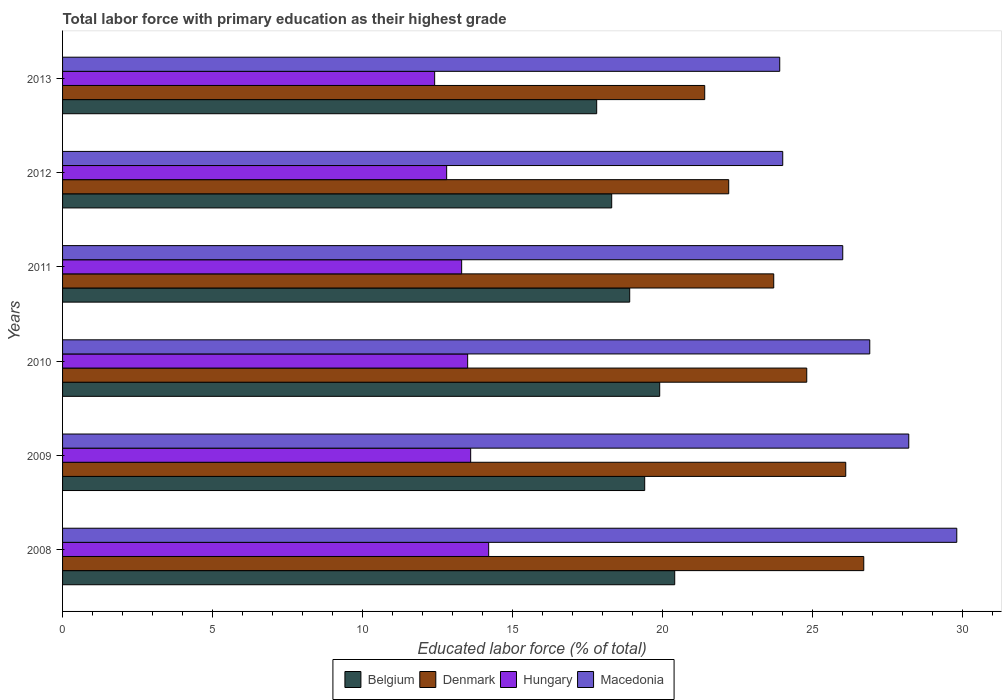How many groups of bars are there?
Ensure brevity in your answer.  6. Are the number of bars per tick equal to the number of legend labels?
Make the answer very short. Yes. How many bars are there on the 6th tick from the top?
Make the answer very short. 4. What is the label of the 2nd group of bars from the top?
Offer a very short reply. 2012. What is the percentage of total labor force with primary education in Hungary in 2013?
Ensure brevity in your answer.  12.4. Across all years, what is the maximum percentage of total labor force with primary education in Denmark?
Offer a terse response. 26.7. Across all years, what is the minimum percentage of total labor force with primary education in Denmark?
Offer a terse response. 21.4. What is the total percentage of total labor force with primary education in Belgium in the graph?
Keep it short and to the point. 114.7. What is the difference between the percentage of total labor force with primary education in Denmark in 2008 and that in 2010?
Offer a very short reply. 1.9. What is the difference between the percentage of total labor force with primary education in Belgium in 2010 and the percentage of total labor force with primary education in Macedonia in 2011?
Your response must be concise. -6.1. What is the average percentage of total labor force with primary education in Macedonia per year?
Make the answer very short. 26.47. In the year 2009, what is the difference between the percentage of total labor force with primary education in Macedonia and percentage of total labor force with primary education in Denmark?
Give a very brief answer. 2.1. What is the ratio of the percentage of total labor force with primary education in Macedonia in 2010 to that in 2011?
Your answer should be very brief. 1.03. What is the difference between the highest and the second highest percentage of total labor force with primary education in Macedonia?
Your response must be concise. 1.6. What is the difference between the highest and the lowest percentage of total labor force with primary education in Belgium?
Your response must be concise. 2.6. In how many years, is the percentage of total labor force with primary education in Denmark greater than the average percentage of total labor force with primary education in Denmark taken over all years?
Provide a succinct answer. 3. Are all the bars in the graph horizontal?
Make the answer very short. Yes. How many years are there in the graph?
Give a very brief answer. 6. Are the values on the major ticks of X-axis written in scientific E-notation?
Your response must be concise. No. Does the graph contain any zero values?
Your response must be concise. No. What is the title of the graph?
Ensure brevity in your answer.  Total labor force with primary education as their highest grade. Does "Burundi" appear as one of the legend labels in the graph?
Your response must be concise. No. What is the label or title of the X-axis?
Provide a short and direct response. Educated labor force (% of total). What is the Educated labor force (% of total) in Belgium in 2008?
Your answer should be very brief. 20.4. What is the Educated labor force (% of total) of Denmark in 2008?
Provide a short and direct response. 26.7. What is the Educated labor force (% of total) of Hungary in 2008?
Your answer should be very brief. 14.2. What is the Educated labor force (% of total) of Macedonia in 2008?
Give a very brief answer. 29.8. What is the Educated labor force (% of total) in Belgium in 2009?
Provide a succinct answer. 19.4. What is the Educated labor force (% of total) of Denmark in 2009?
Offer a very short reply. 26.1. What is the Educated labor force (% of total) of Hungary in 2009?
Offer a terse response. 13.6. What is the Educated labor force (% of total) of Macedonia in 2009?
Offer a terse response. 28.2. What is the Educated labor force (% of total) in Belgium in 2010?
Ensure brevity in your answer.  19.9. What is the Educated labor force (% of total) of Denmark in 2010?
Your answer should be very brief. 24.8. What is the Educated labor force (% of total) of Macedonia in 2010?
Your answer should be very brief. 26.9. What is the Educated labor force (% of total) of Belgium in 2011?
Offer a terse response. 18.9. What is the Educated labor force (% of total) in Denmark in 2011?
Offer a very short reply. 23.7. What is the Educated labor force (% of total) in Hungary in 2011?
Offer a very short reply. 13.3. What is the Educated labor force (% of total) of Macedonia in 2011?
Make the answer very short. 26. What is the Educated labor force (% of total) of Belgium in 2012?
Your answer should be compact. 18.3. What is the Educated labor force (% of total) of Denmark in 2012?
Your answer should be compact. 22.2. What is the Educated labor force (% of total) in Hungary in 2012?
Your response must be concise. 12.8. What is the Educated labor force (% of total) of Macedonia in 2012?
Offer a terse response. 24. What is the Educated labor force (% of total) of Belgium in 2013?
Your answer should be very brief. 17.8. What is the Educated labor force (% of total) of Denmark in 2013?
Provide a short and direct response. 21.4. What is the Educated labor force (% of total) in Hungary in 2013?
Your response must be concise. 12.4. What is the Educated labor force (% of total) in Macedonia in 2013?
Provide a succinct answer. 23.9. Across all years, what is the maximum Educated labor force (% of total) in Belgium?
Keep it short and to the point. 20.4. Across all years, what is the maximum Educated labor force (% of total) of Denmark?
Give a very brief answer. 26.7. Across all years, what is the maximum Educated labor force (% of total) in Hungary?
Ensure brevity in your answer.  14.2. Across all years, what is the maximum Educated labor force (% of total) of Macedonia?
Your answer should be compact. 29.8. Across all years, what is the minimum Educated labor force (% of total) in Belgium?
Make the answer very short. 17.8. Across all years, what is the minimum Educated labor force (% of total) in Denmark?
Make the answer very short. 21.4. Across all years, what is the minimum Educated labor force (% of total) of Hungary?
Offer a terse response. 12.4. Across all years, what is the minimum Educated labor force (% of total) of Macedonia?
Make the answer very short. 23.9. What is the total Educated labor force (% of total) of Belgium in the graph?
Give a very brief answer. 114.7. What is the total Educated labor force (% of total) of Denmark in the graph?
Keep it short and to the point. 144.9. What is the total Educated labor force (% of total) in Hungary in the graph?
Keep it short and to the point. 79.8. What is the total Educated labor force (% of total) of Macedonia in the graph?
Your answer should be very brief. 158.8. What is the difference between the Educated labor force (% of total) in Macedonia in 2008 and that in 2010?
Provide a succinct answer. 2.9. What is the difference between the Educated labor force (% of total) in Denmark in 2008 and that in 2011?
Provide a short and direct response. 3. What is the difference between the Educated labor force (% of total) of Macedonia in 2008 and that in 2011?
Provide a succinct answer. 3.8. What is the difference between the Educated labor force (% of total) of Belgium in 2008 and that in 2012?
Your response must be concise. 2.1. What is the difference between the Educated labor force (% of total) of Denmark in 2008 and that in 2012?
Offer a very short reply. 4.5. What is the difference between the Educated labor force (% of total) of Hungary in 2008 and that in 2012?
Give a very brief answer. 1.4. What is the difference between the Educated labor force (% of total) in Macedonia in 2008 and that in 2012?
Provide a succinct answer. 5.8. What is the difference between the Educated labor force (% of total) of Belgium in 2008 and that in 2013?
Your answer should be very brief. 2.6. What is the difference between the Educated labor force (% of total) of Denmark in 2008 and that in 2013?
Ensure brevity in your answer.  5.3. What is the difference between the Educated labor force (% of total) in Belgium in 2009 and that in 2010?
Offer a terse response. -0.5. What is the difference between the Educated labor force (% of total) of Denmark in 2009 and that in 2010?
Your answer should be compact. 1.3. What is the difference between the Educated labor force (% of total) of Hungary in 2009 and that in 2010?
Make the answer very short. 0.1. What is the difference between the Educated labor force (% of total) of Macedonia in 2009 and that in 2010?
Make the answer very short. 1.3. What is the difference between the Educated labor force (% of total) of Macedonia in 2009 and that in 2011?
Your answer should be very brief. 2.2. What is the difference between the Educated labor force (% of total) in Hungary in 2009 and that in 2012?
Keep it short and to the point. 0.8. What is the difference between the Educated labor force (% of total) of Macedonia in 2009 and that in 2012?
Make the answer very short. 4.2. What is the difference between the Educated labor force (% of total) of Belgium in 2009 and that in 2013?
Give a very brief answer. 1.6. What is the difference between the Educated labor force (% of total) in Hungary in 2009 and that in 2013?
Give a very brief answer. 1.2. What is the difference between the Educated labor force (% of total) in Macedonia in 2009 and that in 2013?
Offer a very short reply. 4.3. What is the difference between the Educated labor force (% of total) of Denmark in 2010 and that in 2011?
Your answer should be very brief. 1.1. What is the difference between the Educated labor force (% of total) in Denmark in 2010 and that in 2012?
Ensure brevity in your answer.  2.6. What is the difference between the Educated labor force (% of total) in Hungary in 2010 and that in 2012?
Ensure brevity in your answer.  0.7. What is the difference between the Educated labor force (% of total) in Belgium in 2010 and that in 2013?
Keep it short and to the point. 2.1. What is the difference between the Educated labor force (% of total) in Denmark in 2011 and that in 2012?
Your response must be concise. 1.5. What is the difference between the Educated labor force (% of total) in Hungary in 2011 and that in 2012?
Keep it short and to the point. 0.5. What is the difference between the Educated labor force (% of total) of Macedonia in 2011 and that in 2012?
Offer a very short reply. 2. What is the difference between the Educated labor force (% of total) in Macedonia in 2011 and that in 2013?
Your answer should be compact. 2.1. What is the difference between the Educated labor force (% of total) in Belgium in 2012 and that in 2013?
Your answer should be compact. 0.5. What is the difference between the Educated labor force (% of total) in Hungary in 2012 and that in 2013?
Your answer should be very brief. 0.4. What is the difference between the Educated labor force (% of total) in Belgium in 2008 and the Educated labor force (% of total) in Denmark in 2009?
Give a very brief answer. -5.7. What is the difference between the Educated labor force (% of total) of Denmark in 2008 and the Educated labor force (% of total) of Hungary in 2009?
Offer a terse response. 13.1. What is the difference between the Educated labor force (% of total) in Hungary in 2008 and the Educated labor force (% of total) in Macedonia in 2009?
Ensure brevity in your answer.  -14. What is the difference between the Educated labor force (% of total) of Belgium in 2008 and the Educated labor force (% of total) of Hungary in 2010?
Make the answer very short. 6.9. What is the difference between the Educated labor force (% of total) in Denmark in 2008 and the Educated labor force (% of total) in Macedonia in 2010?
Your response must be concise. -0.2. What is the difference between the Educated labor force (% of total) of Belgium in 2008 and the Educated labor force (% of total) of Macedonia in 2011?
Make the answer very short. -5.6. What is the difference between the Educated labor force (% of total) of Denmark in 2008 and the Educated labor force (% of total) of Hungary in 2011?
Keep it short and to the point. 13.4. What is the difference between the Educated labor force (% of total) of Denmark in 2008 and the Educated labor force (% of total) of Macedonia in 2011?
Give a very brief answer. 0.7. What is the difference between the Educated labor force (% of total) in Hungary in 2008 and the Educated labor force (% of total) in Macedonia in 2011?
Offer a terse response. -11.8. What is the difference between the Educated labor force (% of total) of Belgium in 2008 and the Educated labor force (% of total) of Denmark in 2012?
Keep it short and to the point. -1.8. What is the difference between the Educated labor force (% of total) in Denmark in 2008 and the Educated labor force (% of total) in Hungary in 2012?
Your answer should be compact. 13.9. What is the difference between the Educated labor force (% of total) of Belgium in 2008 and the Educated labor force (% of total) of Denmark in 2013?
Keep it short and to the point. -1. What is the difference between the Educated labor force (% of total) in Belgium in 2008 and the Educated labor force (% of total) in Hungary in 2013?
Offer a terse response. 8. What is the difference between the Educated labor force (% of total) in Belgium in 2008 and the Educated labor force (% of total) in Macedonia in 2013?
Make the answer very short. -3.5. What is the difference between the Educated labor force (% of total) of Denmark in 2008 and the Educated labor force (% of total) of Macedonia in 2013?
Give a very brief answer. 2.8. What is the difference between the Educated labor force (% of total) in Belgium in 2009 and the Educated labor force (% of total) in Hungary in 2010?
Make the answer very short. 5.9. What is the difference between the Educated labor force (% of total) in Belgium in 2009 and the Educated labor force (% of total) in Macedonia in 2010?
Offer a terse response. -7.5. What is the difference between the Educated labor force (% of total) of Belgium in 2009 and the Educated labor force (% of total) of Hungary in 2011?
Provide a succinct answer. 6.1. What is the difference between the Educated labor force (% of total) of Belgium in 2009 and the Educated labor force (% of total) of Macedonia in 2011?
Your response must be concise. -6.6. What is the difference between the Educated labor force (% of total) of Denmark in 2009 and the Educated labor force (% of total) of Hungary in 2011?
Your answer should be very brief. 12.8. What is the difference between the Educated labor force (% of total) in Denmark in 2009 and the Educated labor force (% of total) in Macedonia in 2011?
Offer a terse response. 0.1. What is the difference between the Educated labor force (% of total) of Hungary in 2009 and the Educated labor force (% of total) of Macedonia in 2011?
Give a very brief answer. -12.4. What is the difference between the Educated labor force (% of total) of Belgium in 2009 and the Educated labor force (% of total) of Macedonia in 2012?
Offer a very short reply. -4.6. What is the difference between the Educated labor force (% of total) of Denmark in 2009 and the Educated labor force (% of total) of Macedonia in 2012?
Provide a short and direct response. 2.1. What is the difference between the Educated labor force (% of total) of Hungary in 2009 and the Educated labor force (% of total) of Macedonia in 2012?
Offer a very short reply. -10.4. What is the difference between the Educated labor force (% of total) of Belgium in 2009 and the Educated labor force (% of total) of Denmark in 2013?
Make the answer very short. -2. What is the difference between the Educated labor force (% of total) of Belgium in 2009 and the Educated labor force (% of total) of Hungary in 2013?
Keep it short and to the point. 7. What is the difference between the Educated labor force (% of total) in Denmark in 2009 and the Educated labor force (% of total) in Hungary in 2013?
Your answer should be compact. 13.7. What is the difference between the Educated labor force (% of total) in Hungary in 2009 and the Educated labor force (% of total) in Macedonia in 2013?
Provide a succinct answer. -10.3. What is the difference between the Educated labor force (% of total) of Belgium in 2010 and the Educated labor force (% of total) of Hungary in 2011?
Keep it short and to the point. 6.6. What is the difference between the Educated labor force (% of total) of Denmark in 2010 and the Educated labor force (% of total) of Macedonia in 2011?
Keep it short and to the point. -1.2. What is the difference between the Educated labor force (% of total) of Belgium in 2010 and the Educated labor force (% of total) of Macedonia in 2012?
Offer a very short reply. -4.1. What is the difference between the Educated labor force (% of total) in Denmark in 2010 and the Educated labor force (% of total) in Macedonia in 2012?
Offer a very short reply. 0.8. What is the difference between the Educated labor force (% of total) in Belgium in 2010 and the Educated labor force (% of total) in Denmark in 2013?
Your response must be concise. -1.5. What is the difference between the Educated labor force (% of total) of Denmark in 2010 and the Educated labor force (% of total) of Macedonia in 2013?
Make the answer very short. 0.9. What is the difference between the Educated labor force (% of total) of Belgium in 2011 and the Educated labor force (% of total) of Denmark in 2012?
Your response must be concise. -3.3. What is the difference between the Educated labor force (% of total) of Belgium in 2011 and the Educated labor force (% of total) of Hungary in 2012?
Make the answer very short. 6.1. What is the difference between the Educated labor force (% of total) of Belgium in 2011 and the Educated labor force (% of total) of Macedonia in 2012?
Provide a short and direct response. -5.1. What is the difference between the Educated labor force (% of total) of Denmark in 2011 and the Educated labor force (% of total) of Hungary in 2012?
Your answer should be compact. 10.9. What is the difference between the Educated labor force (% of total) in Belgium in 2011 and the Educated labor force (% of total) in Denmark in 2013?
Give a very brief answer. -2.5. What is the difference between the Educated labor force (% of total) in Belgium in 2011 and the Educated labor force (% of total) in Hungary in 2013?
Offer a very short reply. 6.5. What is the difference between the Educated labor force (% of total) in Belgium in 2011 and the Educated labor force (% of total) in Macedonia in 2013?
Provide a succinct answer. -5. What is the difference between the Educated labor force (% of total) in Denmark in 2011 and the Educated labor force (% of total) in Macedonia in 2013?
Make the answer very short. -0.2. What is the difference between the Educated labor force (% of total) in Hungary in 2011 and the Educated labor force (% of total) in Macedonia in 2013?
Your answer should be very brief. -10.6. What is the difference between the Educated labor force (% of total) in Hungary in 2012 and the Educated labor force (% of total) in Macedonia in 2013?
Provide a succinct answer. -11.1. What is the average Educated labor force (% of total) in Belgium per year?
Give a very brief answer. 19.12. What is the average Educated labor force (% of total) of Denmark per year?
Offer a very short reply. 24.15. What is the average Educated labor force (% of total) in Macedonia per year?
Provide a succinct answer. 26.47. In the year 2008, what is the difference between the Educated labor force (% of total) of Denmark and Educated labor force (% of total) of Hungary?
Offer a terse response. 12.5. In the year 2008, what is the difference between the Educated labor force (% of total) of Hungary and Educated labor force (% of total) of Macedonia?
Provide a short and direct response. -15.6. In the year 2009, what is the difference between the Educated labor force (% of total) of Belgium and Educated labor force (% of total) of Denmark?
Provide a short and direct response. -6.7. In the year 2009, what is the difference between the Educated labor force (% of total) of Belgium and Educated labor force (% of total) of Hungary?
Your answer should be compact. 5.8. In the year 2009, what is the difference between the Educated labor force (% of total) in Belgium and Educated labor force (% of total) in Macedonia?
Your answer should be very brief. -8.8. In the year 2009, what is the difference between the Educated labor force (% of total) of Hungary and Educated labor force (% of total) of Macedonia?
Give a very brief answer. -14.6. In the year 2010, what is the difference between the Educated labor force (% of total) of Belgium and Educated labor force (% of total) of Denmark?
Your answer should be very brief. -4.9. In the year 2010, what is the difference between the Educated labor force (% of total) of Belgium and Educated labor force (% of total) of Hungary?
Make the answer very short. 6.4. In the year 2010, what is the difference between the Educated labor force (% of total) in Belgium and Educated labor force (% of total) in Macedonia?
Provide a short and direct response. -7. In the year 2010, what is the difference between the Educated labor force (% of total) of Hungary and Educated labor force (% of total) of Macedonia?
Keep it short and to the point. -13.4. In the year 2011, what is the difference between the Educated labor force (% of total) of Belgium and Educated labor force (% of total) of Denmark?
Offer a very short reply. -4.8. In the year 2011, what is the difference between the Educated labor force (% of total) of Belgium and Educated labor force (% of total) of Hungary?
Your response must be concise. 5.6. In the year 2011, what is the difference between the Educated labor force (% of total) of Belgium and Educated labor force (% of total) of Macedonia?
Give a very brief answer. -7.1. In the year 2011, what is the difference between the Educated labor force (% of total) in Denmark and Educated labor force (% of total) in Hungary?
Your response must be concise. 10.4. In the year 2011, what is the difference between the Educated labor force (% of total) in Denmark and Educated labor force (% of total) in Macedonia?
Your answer should be very brief. -2.3. In the year 2012, what is the difference between the Educated labor force (% of total) in Belgium and Educated labor force (% of total) in Denmark?
Offer a very short reply. -3.9. In the year 2012, what is the difference between the Educated labor force (% of total) in Belgium and Educated labor force (% of total) in Macedonia?
Ensure brevity in your answer.  -5.7. In the year 2012, what is the difference between the Educated labor force (% of total) of Denmark and Educated labor force (% of total) of Macedonia?
Make the answer very short. -1.8. In the year 2012, what is the difference between the Educated labor force (% of total) in Hungary and Educated labor force (% of total) in Macedonia?
Your response must be concise. -11.2. In the year 2013, what is the difference between the Educated labor force (% of total) in Belgium and Educated labor force (% of total) in Denmark?
Your response must be concise. -3.6. In the year 2013, what is the difference between the Educated labor force (% of total) in Belgium and Educated labor force (% of total) in Hungary?
Make the answer very short. 5.4. In the year 2013, what is the difference between the Educated labor force (% of total) in Denmark and Educated labor force (% of total) in Macedonia?
Provide a succinct answer. -2.5. What is the ratio of the Educated labor force (% of total) of Belgium in 2008 to that in 2009?
Offer a very short reply. 1.05. What is the ratio of the Educated labor force (% of total) in Denmark in 2008 to that in 2009?
Provide a succinct answer. 1.02. What is the ratio of the Educated labor force (% of total) in Hungary in 2008 to that in 2009?
Ensure brevity in your answer.  1.04. What is the ratio of the Educated labor force (% of total) in Macedonia in 2008 to that in 2009?
Your answer should be very brief. 1.06. What is the ratio of the Educated labor force (% of total) in Belgium in 2008 to that in 2010?
Make the answer very short. 1.03. What is the ratio of the Educated labor force (% of total) in Denmark in 2008 to that in 2010?
Keep it short and to the point. 1.08. What is the ratio of the Educated labor force (% of total) in Hungary in 2008 to that in 2010?
Your response must be concise. 1.05. What is the ratio of the Educated labor force (% of total) in Macedonia in 2008 to that in 2010?
Offer a very short reply. 1.11. What is the ratio of the Educated labor force (% of total) of Belgium in 2008 to that in 2011?
Offer a terse response. 1.08. What is the ratio of the Educated labor force (% of total) of Denmark in 2008 to that in 2011?
Offer a very short reply. 1.13. What is the ratio of the Educated labor force (% of total) in Hungary in 2008 to that in 2011?
Your answer should be compact. 1.07. What is the ratio of the Educated labor force (% of total) in Macedonia in 2008 to that in 2011?
Give a very brief answer. 1.15. What is the ratio of the Educated labor force (% of total) in Belgium in 2008 to that in 2012?
Keep it short and to the point. 1.11. What is the ratio of the Educated labor force (% of total) in Denmark in 2008 to that in 2012?
Your answer should be very brief. 1.2. What is the ratio of the Educated labor force (% of total) in Hungary in 2008 to that in 2012?
Provide a succinct answer. 1.11. What is the ratio of the Educated labor force (% of total) of Macedonia in 2008 to that in 2012?
Your response must be concise. 1.24. What is the ratio of the Educated labor force (% of total) of Belgium in 2008 to that in 2013?
Provide a short and direct response. 1.15. What is the ratio of the Educated labor force (% of total) of Denmark in 2008 to that in 2013?
Offer a very short reply. 1.25. What is the ratio of the Educated labor force (% of total) in Hungary in 2008 to that in 2013?
Your answer should be very brief. 1.15. What is the ratio of the Educated labor force (% of total) of Macedonia in 2008 to that in 2013?
Provide a succinct answer. 1.25. What is the ratio of the Educated labor force (% of total) in Belgium in 2009 to that in 2010?
Provide a short and direct response. 0.97. What is the ratio of the Educated labor force (% of total) in Denmark in 2009 to that in 2010?
Keep it short and to the point. 1.05. What is the ratio of the Educated labor force (% of total) in Hungary in 2009 to that in 2010?
Give a very brief answer. 1.01. What is the ratio of the Educated labor force (% of total) of Macedonia in 2009 to that in 2010?
Offer a very short reply. 1.05. What is the ratio of the Educated labor force (% of total) in Belgium in 2009 to that in 2011?
Give a very brief answer. 1.03. What is the ratio of the Educated labor force (% of total) of Denmark in 2009 to that in 2011?
Your response must be concise. 1.1. What is the ratio of the Educated labor force (% of total) in Hungary in 2009 to that in 2011?
Provide a short and direct response. 1.02. What is the ratio of the Educated labor force (% of total) of Macedonia in 2009 to that in 2011?
Make the answer very short. 1.08. What is the ratio of the Educated labor force (% of total) in Belgium in 2009 to that in 2012?
Your answer should be very brief. 1.06. What is the ratio of the Educated labor force (% of total) in Denmark in 2009 to that in 2012?
Make the answer very short. 1.18. What is the ratio of the Educated labor force (% of total) of Hungary in 2009 to that in 2012?
Offer a terse response. 1.06. What is the ratio of the Educated labor force (% of total) in Macedonia in 2009 to that in 2012?
Provide a succinct answer. 1.18. What is the ratio of the Educated labor force (% of total) of Belgium in 2009 to that in 2013?
Offer a very short reply. 1.09. What is the ratio of the Educated labor force (% of total) in Denmark in 2009 to that in 2013?
Offer a terse response. 1.22. What is the ratio of the Educated labor force (% of total) in Hungary in 2009 to that in 2013?
Your answer should be very brief. 1.1. What is the ratio of the Educated labor force (% of total) in Macedonia in 2009 to that in 2013?
Make the answer very short. 1.18. What is the ratio of the Educated labor force (% of total) in Belgium in 2010 to that in 2011?
Your response must be concise. 1.05. What is the ratio of the Educated labor force (% of total) in Denmark in 2010 to that in 2011?
Keep it short and to the point. 1.05. What is the ratio of the Educated labor force (% of total) in Hungary in 2010 to that in 2011?
Offer a very short reply. 1.01. What is the ratio of the Educated labor force (% of total) of Macedonia in 2010 to that in 2011?
Offer a terse response. 1.03. What is the ratio of the Educated labor force (% of total) of Belgium in 2010 to that in 2012?
Make the answer very short. 1.09. What is the ratio of the Educated labor force (% of total) in Denmark in 2010 to that in 2012?
Make the answer very short. 1.12. What is the ratio of the Educated labor force (% of total) in Hungary in 2010 to that in 2012?
Give a very brief answer. 1.05. What is the ratio of the Educated labor force (% of total) of Macedonia in 2010 to that in 2012?
Provide a succinct answer. 1.12. What is the ratio of the Educated labor force (% of total) of Belgium in 2010 to that in 2013?
Provide a short and direct response. 1.12. What is the ratio of the Educated labor force (% of total) of Denmark in 2010 to that in 2013?
Offer a terse response. 1.16. What is the ratio of the Educated labor force (% of total) of Hungary in 2010 to that in 2013?
Your response must be concise. 1.09. What is the ratio of the Educated labor force (% of total) in Macedonia in 2010 to that in 2013?
Offer a terse response. 1.13. What is the ratio of the Educated labor force (% of total) in Belgium in 2011 to that in 2012?
Ensure brevity in your answer.  1.03. What is the ratio of the Educated labor force (% of total) in Denmark in 2011 to that in 2012?
Offer a very short reply. 1.07. What is the ratio of the Educated labor force (% of total) in Hungary in 2011 to that in 2012?
Your response must be concise. 1.04. What is the ratio of the Educated labor force (% of total) of Macedonia in 2011 to that in 2012?
Your response must be concise. 1.08. What is the ratio of the Educated labor force (% of total) in Belgium in 2011 to that in 2013?
Your answer should be very brief. 1.06. What is the ratio of the Educated labor force (% of total) of Denmark in 2011 to that in 2013?
Your answer should be compact. 1.11. What is the ratio of the Educated labor force (% of total) of Hungary in 2011 to that in 2013?
Give a very brief answer. 1.07. What is the ratio of the Educated labor force (% of total) in Macedonia in 2011 to that in 2013?
Ensure brevity in your answer.  1.09. What is the ratio of the Educated labor force (% of total) of Belgium in 2012 to that in 2013?
Provide a succinct answer. 1.03. What is the ratio of the Educated labor force (% of total) in Denmark in 2012 to that in 2013?
Keep it short and to the point. 1.04. What is the ratio of the Educated labor force (% of total) in Hungary in 2012 to that in 2013?
Provide a succinct answer. 1.03. What is the difference between the highest and the second highest Educated labor force (% of total) in Belgium?
Your response must be concise. 0.5. What is the difference between the highest and the second highest Educated labor force (% of total) of Denmark?
Your answer should be compact. 0.6. What is the difference between the highest and the second highest Educated labor force (% of total) of Hungary?
Make the answer very short. 0.6. What is the difference between the highest and the lowest Educated labor force (% of total) of Belgium?
Keep it short and to the point. 2.6. What is the difference between the highest and the lowest Educated labor force (% of total) in Denmark?
Your answer should be compact. 5.3. What is the difference between the highest and the lowest Educated labor force (% of total) in Hungary?
Your answer should be very brief. 1.8. 